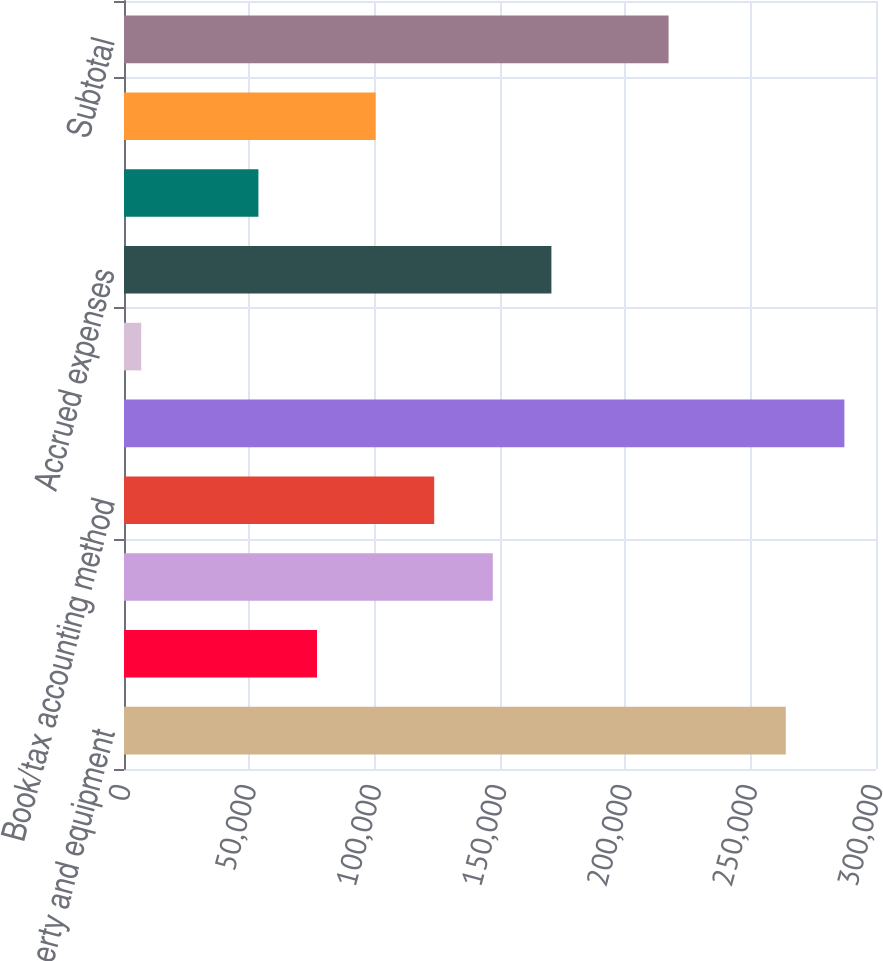Convert chart to OTSL. <chart><loc_0><loc_0><loc_500><loc_500><bar_chart><fcel>Property and equipment<fcel>Goodwill<fcel>Other Intangibles<fcel>Book/tax accounting method<fcel>Total deferred income tax<fcel>Allowance for doubtful<fcel>Accrued expenses<fcel>Net operating loss<fcel>Inventory and other<fcel>Subtotal<nl><fcel>264013<fcel>76997.7<fcel>147128<fcel>123752<fcel>287390<fcel>6867<fcel>170505<fcel>53620.8<fcel>100375<fcel>217259<nl></chart> 